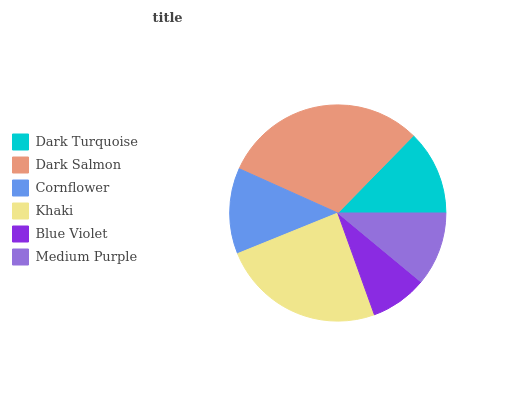Is Blue Violet the minimum?
Answer yes or no. Yes. Is Dark Salmon the maximum?
Answer yes or no. Yes. Is Cornflower the minimum?
Answer yes or no. No. Is Cornflower the maximum?
Answer yes or no. No. Is Dark Salmon greater than Cornflower?
Answer yes or no. Yes. Is Cornflower less than Dark Salmon?
Answer yes or no. Yes. Is Cornflower greater than Dark Salmon?
Answer yes or no. No. Is Dark Salmon less than Cornflower?
Answer yes or no. No. Is Cornflower the high median?
Answer yes or no. Yes. Is Dark Turquoise the low median?
Answer yes or no. Yes. Is Dark Turquoise the high median?
Answer yes or no. No. Is Dark Salmon the low median?
Answer yes or no. No. 